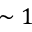Convert formula to latex. <formula><loc_0><loc_0><loc_500><loc_500>\sim 1</formula> 